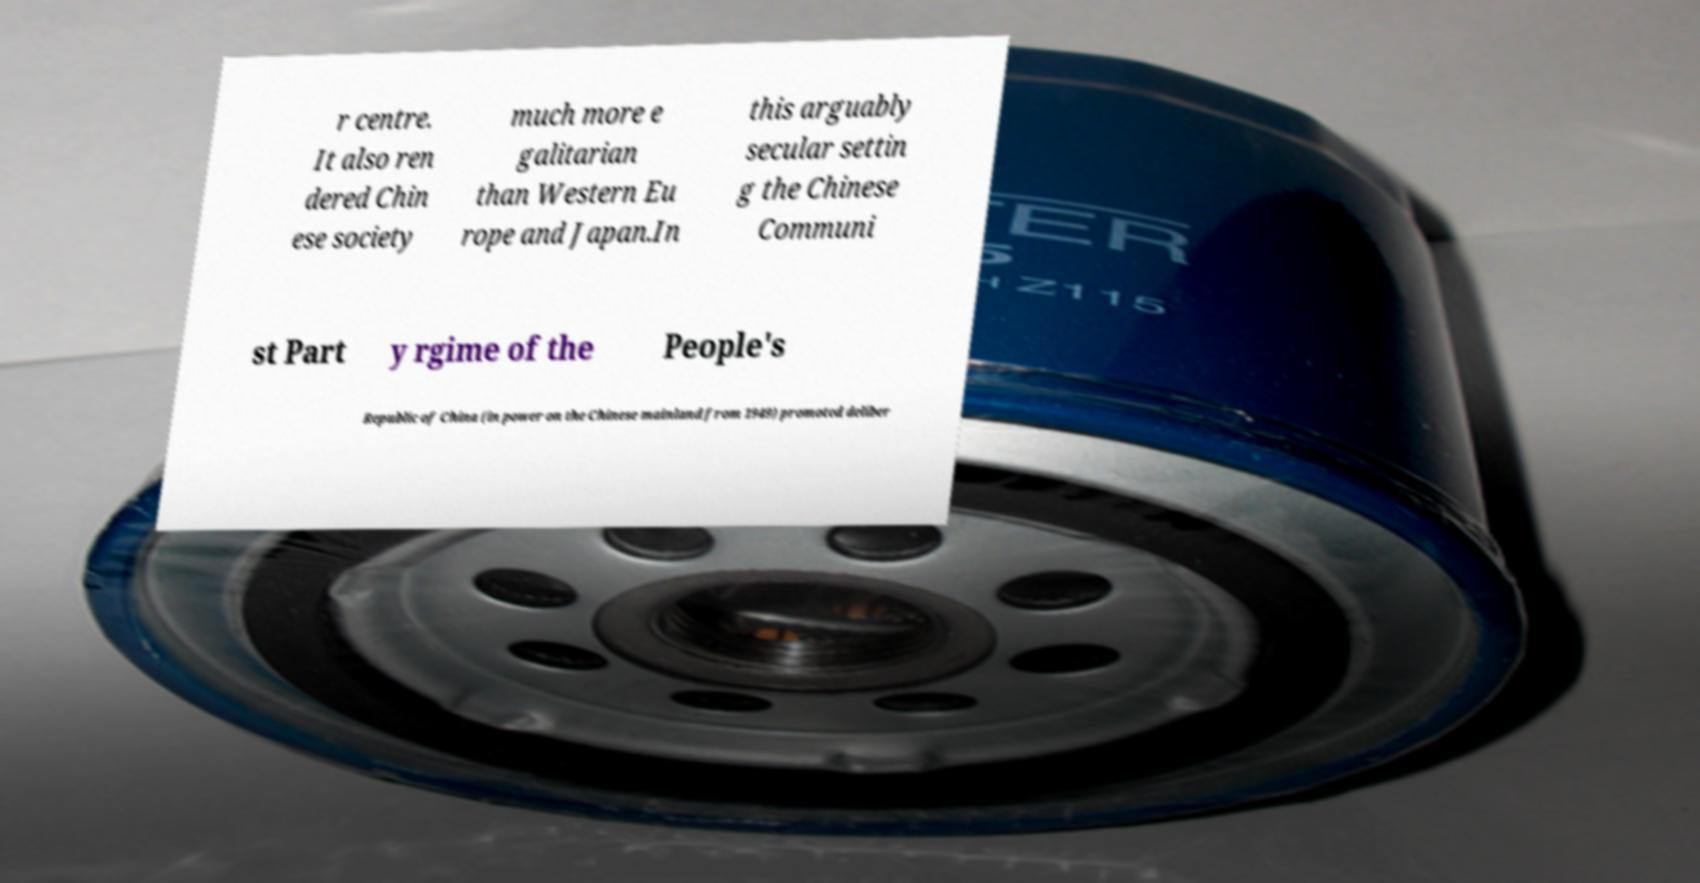Please read and relay the text visible in this image. What does it say? r centre. It also ren dered Chin ese society much more e galitarian than Western Eu rope and Japan.In this arguably secular settin g the Chinese Communi st Part y rgime of the People's Republic of China (in power on the Chinese mainland from 1949) promoted deliber 